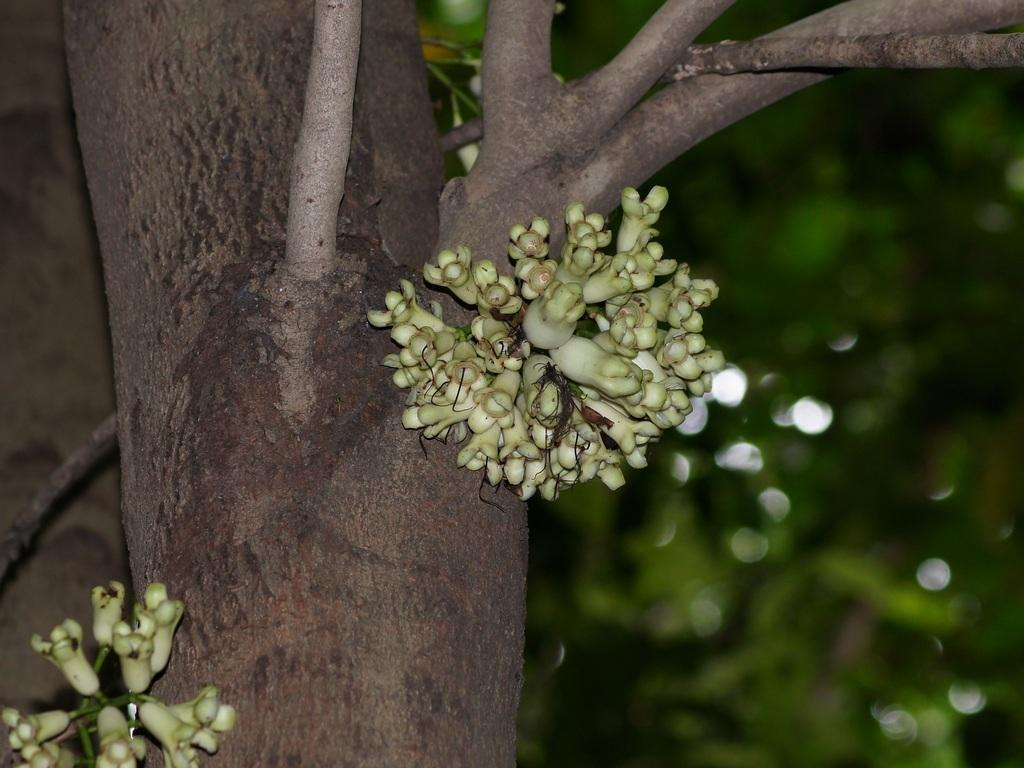What is growing on the tree in the foreground of the image? There are flowers in the bark of a tree in the foreground. What can be seen in the background of the image? There are leaves in the background of the image. What type of camera is visible in the image? There is no camera present in the image. Can you see a robin perched on any branches in the image? There is no robin visible in the image. 